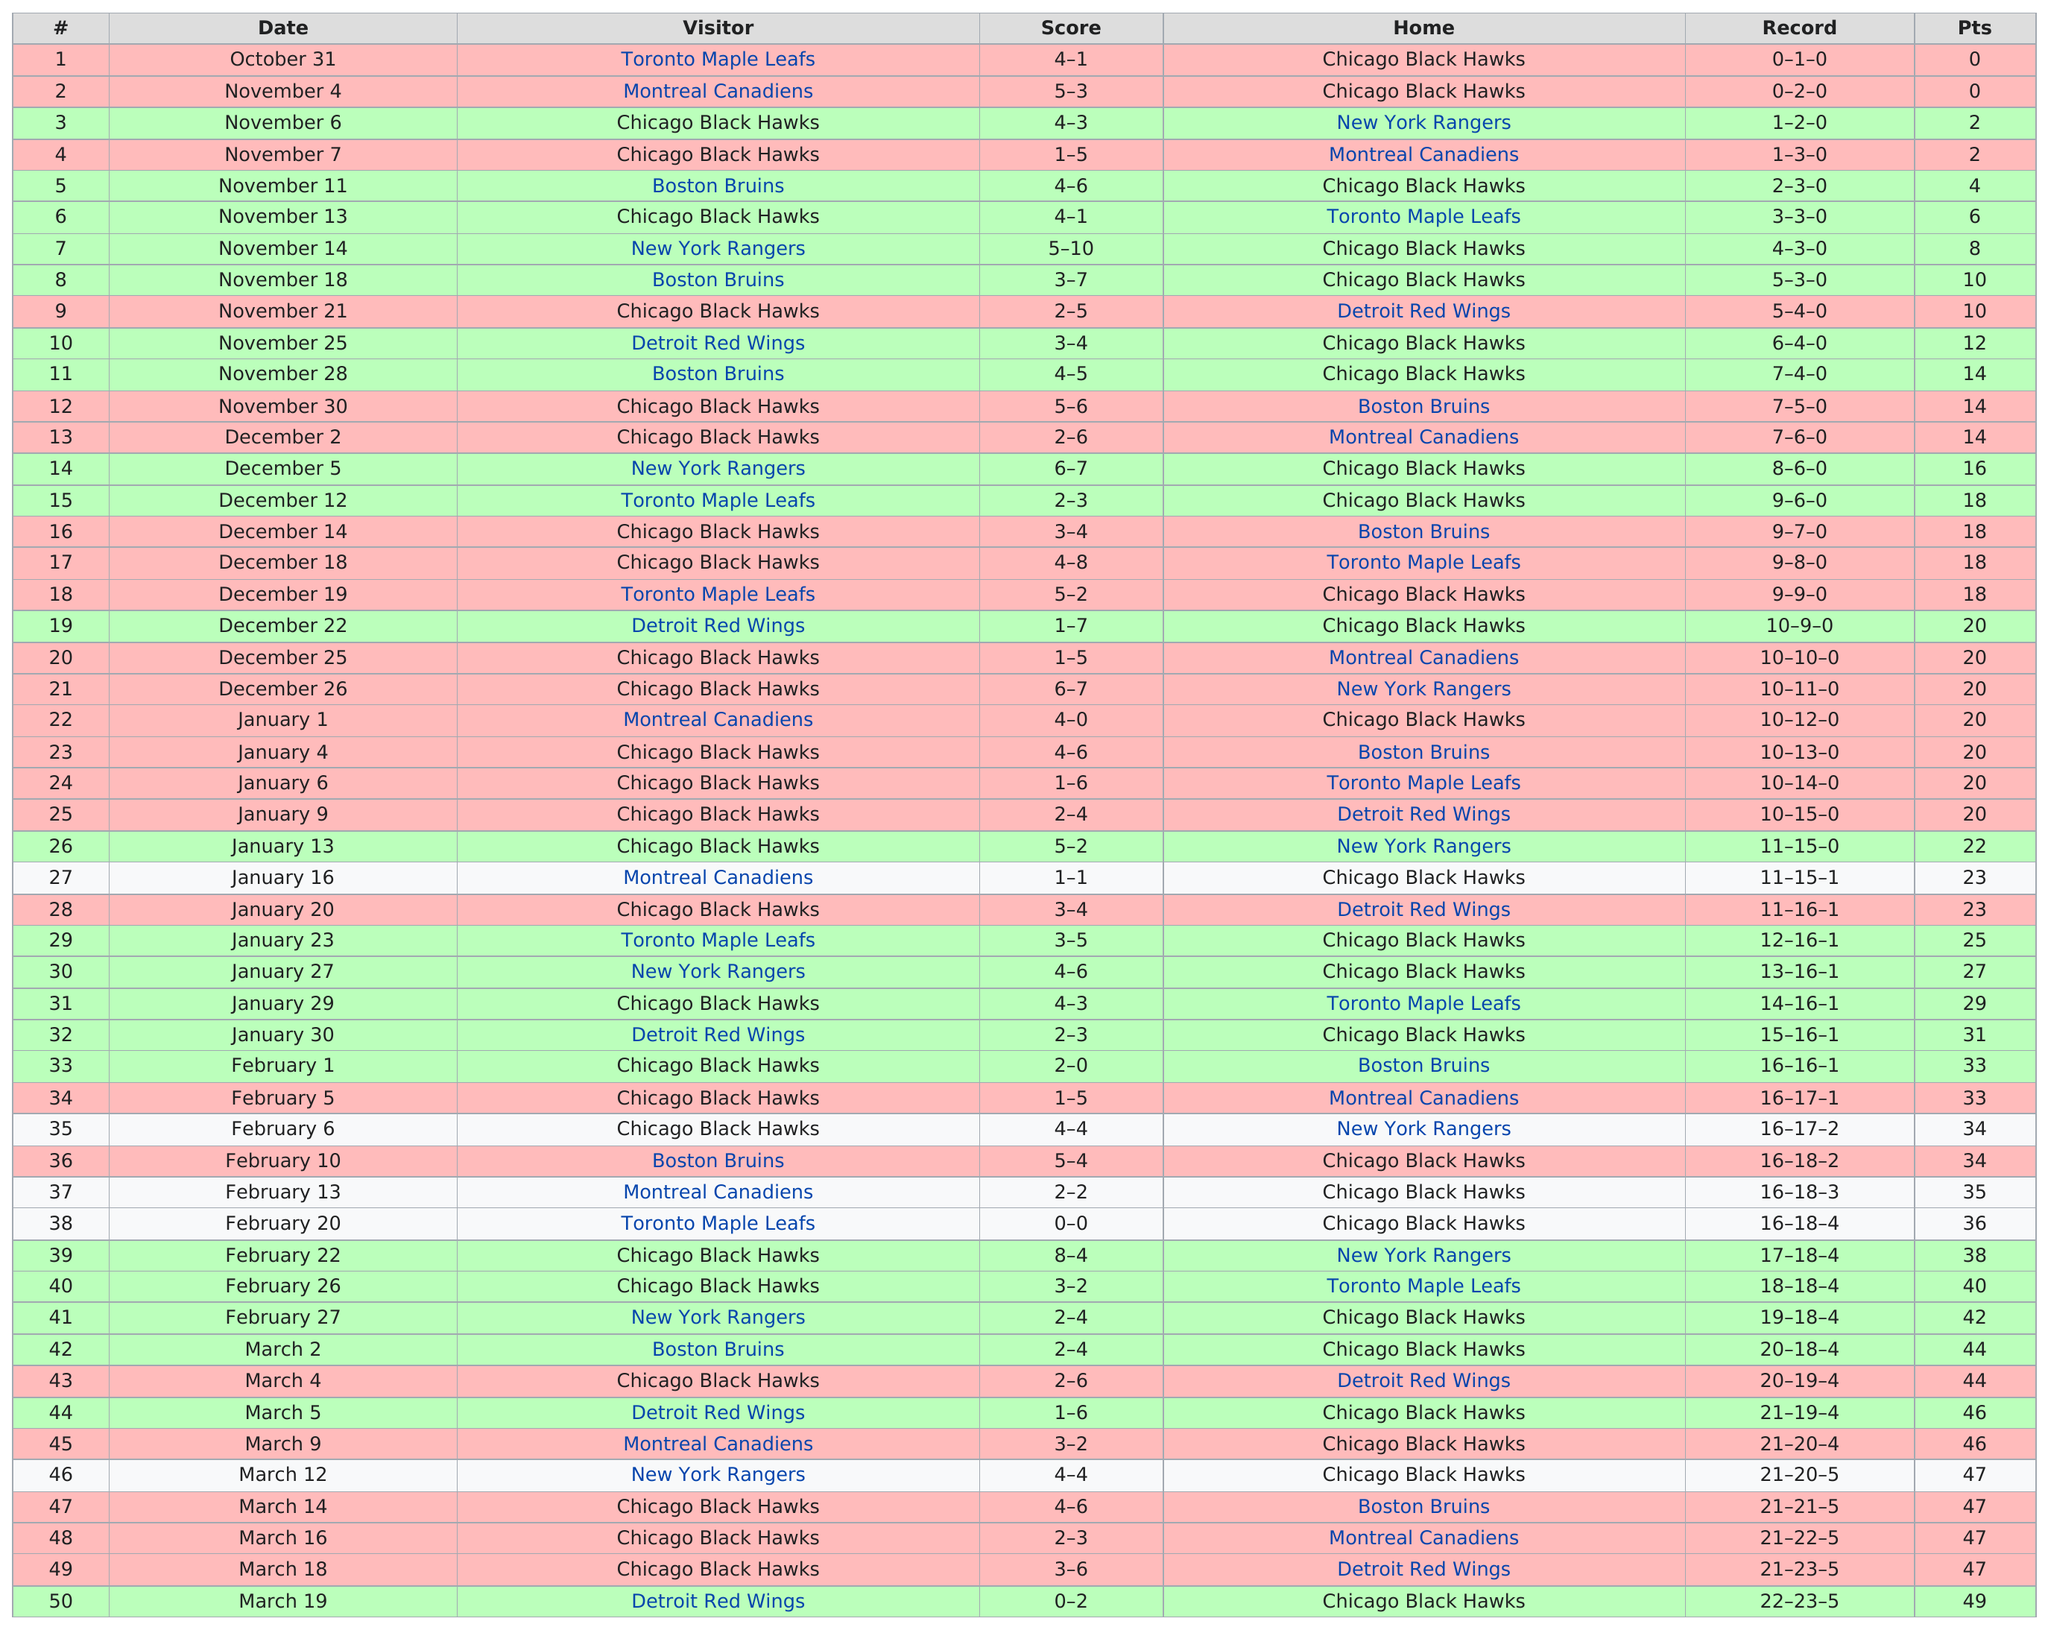Draw attention to some important aspects in this diagram. On December 5th, the difference in points between November 11th is 3. On November 4th, the total amount of points scored was 8. On December 14, the Boston Bruins were the home team, and they defeated the Chicago Black Hawks in a hard-fought game. The total number of games played was 50. In total, they won 22 games. 